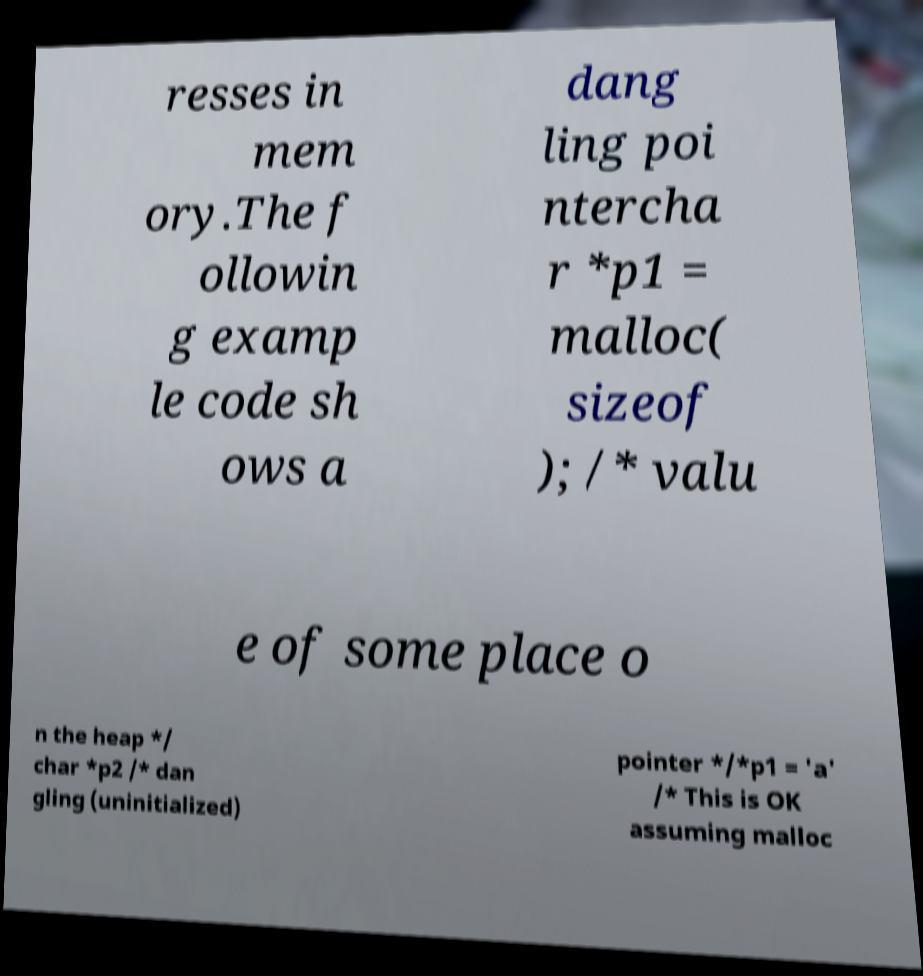Can you accurately transcribe the text from the provided image for me? resses in mem ory.The f ollowin g examp le code sh ows a dang ling poi ntercha r *p1 = malloc( sizeof ); /* valu e of some place o n the heap */ char *p2 /* dan gling (uninitialized) pointer */*p1 = 'a' /* This is OK assuming malloc 